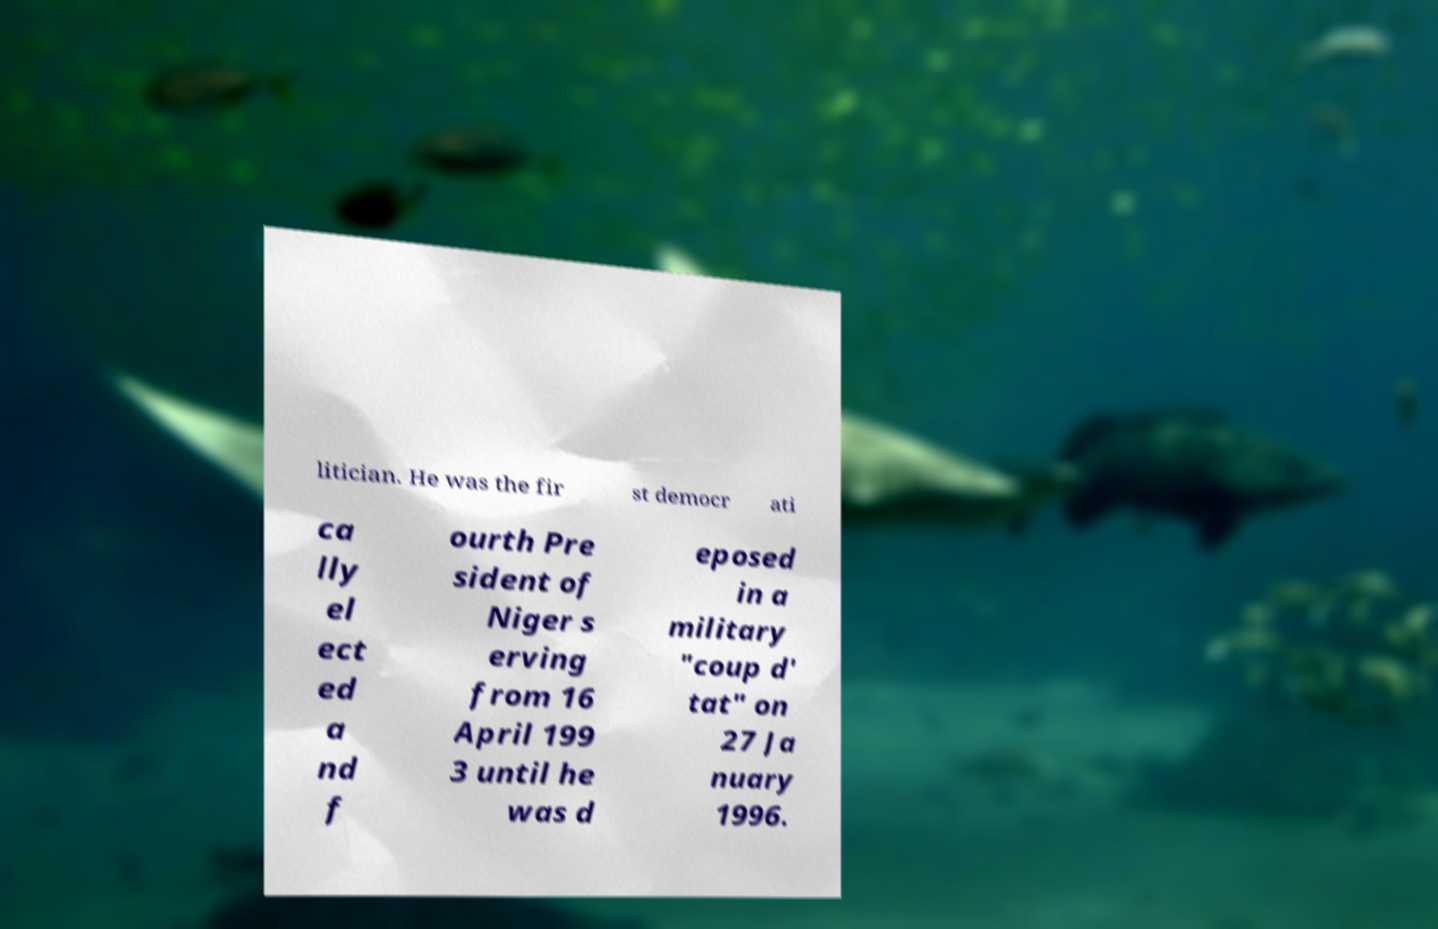Please identify and transcribe the text found in this image. litician. He was the fir st democr ati ca lly el ect ed a nd f ourth Pre sident of Niger s erving from 16 April 199 3 until he was d eposed in a military "coup d' tat" on 27 Ja nuary 1996. 